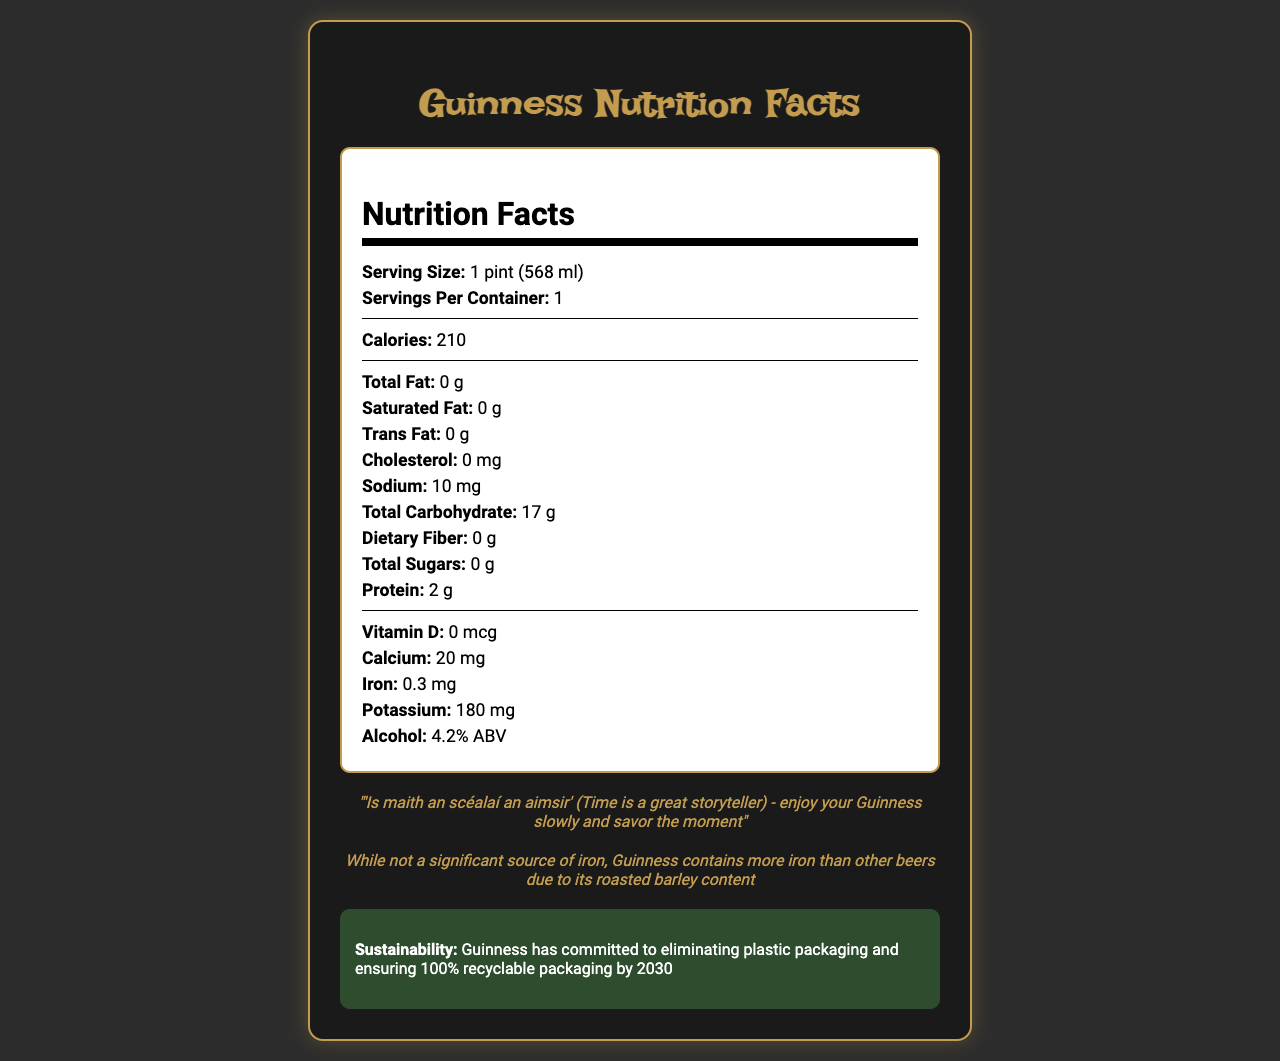what is the serving size for a pint of Guinness? The document states that the serving size for Guinness is 1 pint, which is equivalent to 568 ml.
Answer: 1 pint (568 ml) how many calories are in a pint of Guinness? According to the nutrition facts, there are 210 calories in a pint of Guinness.
Answer: 210 how much iron does a pint of Guinness contain? The document mentions that a pint of Guinness contains 0.3 mg of iron.
Answer: 0.3 mg what is the sodium content in a pint of Guinness? The nutrition label specifies that there are 10 mg of sodium in a pint of Guinness.
Answer: 10 mg what percentage of alcohol does Guinness contain? The document lists the alcohol content of Guinness as 4.2% ABV.
Answer: 4.2% ABV which pairing is suggested for enjoying Guinness? A. Pizza B. Sushi C. Colcannon or Irish stew The document suggests that Guinness is often enjoyed with traditional Irish dishes like colcannon or Irish stew.
Answer: C which Irish folk bands are suggested to listen to while drinking Guinness? A. U2 B. The Dubliners C. Led Zeppelin D. The Chieftains E. Both B and D The document suggests that Guinness is best enjoyed while listening to The Dubliners or The Chieftains.
Answer: E is Guinness a good source of dietary fiber? The document indicates that Guinness contains 0 g of dietary fiber, which means it is not a source of dietary fiber.
Answer: No is the plastic packaging of Guinness sustainable? The document states that Guinness has committed to eliminating plastic packaging and ensuring 100% recyclable packaging by 2030.
Answer: Yes summarize the nutritional and additional information about a pint of Guinness. This summary is derived from the combination of nutrition facts, traditional pairings, music pairings, brewing location, and sustainability information provided in the document.
Answer: A pint of Guinness (568 ml) contains 210 calories, 0 g of total fat, 10 mg of sodium, 17 g of total carbohydrates, 0 g of dietary fiber, 0 g of total sugars, 2 g of protein, and 0.3 mg of iron. It also contains 4.2% ABV. In addition to its nutritional information, the document mentions that Guinness is traditionally enjoyed with Irish dishes like colcannon or Irish stew, often while listening to Irish folk bands like The Dubliners or The Chieftains. Guinness is brewing at St. James's Gate Brewery in Dublin, Ireland, and has a commitment to sustainability by eliminating plastic packaging by 2030. what is the amount of calcium in a pint of Guinness? The document mentions that a pint of Guinness contains 20 mg of calcium.
Answer: 20 mg what is the total carbohydrate content in a pint of Guinness? According to the nutrition facts, there are 17 g of total carbohydrates in a pint of Guinness.
Answer: 17 g how much protein is in a pint of Guinness? The document states that there are 2 g of protein in a pint of Guinness.
Answer: 2 g what is the significance of the iron content in Guinness? The document notes that while Guinness is not a significant source of iron, it does contain more iron than other beers because of its roasted barley.
Answer: Guinness contains more iron than other beers due to its roasted barley content, though it is not a significant source of iron. what does "liquid bread" refer to in Irish folklore? The document states that, in Irish folklore, Guinness was sometimes referred to as "liquid bread" due to its nutritional content.
Answer: Guinness what are the cardiovascular benefits of Guinness? The document mentions that moderate consumption of Guinness, like other alcoholic beverages, may have some cardiovascular benefits, but it does not provide detailed information on what those benefits are.
Answer: Not enough information 